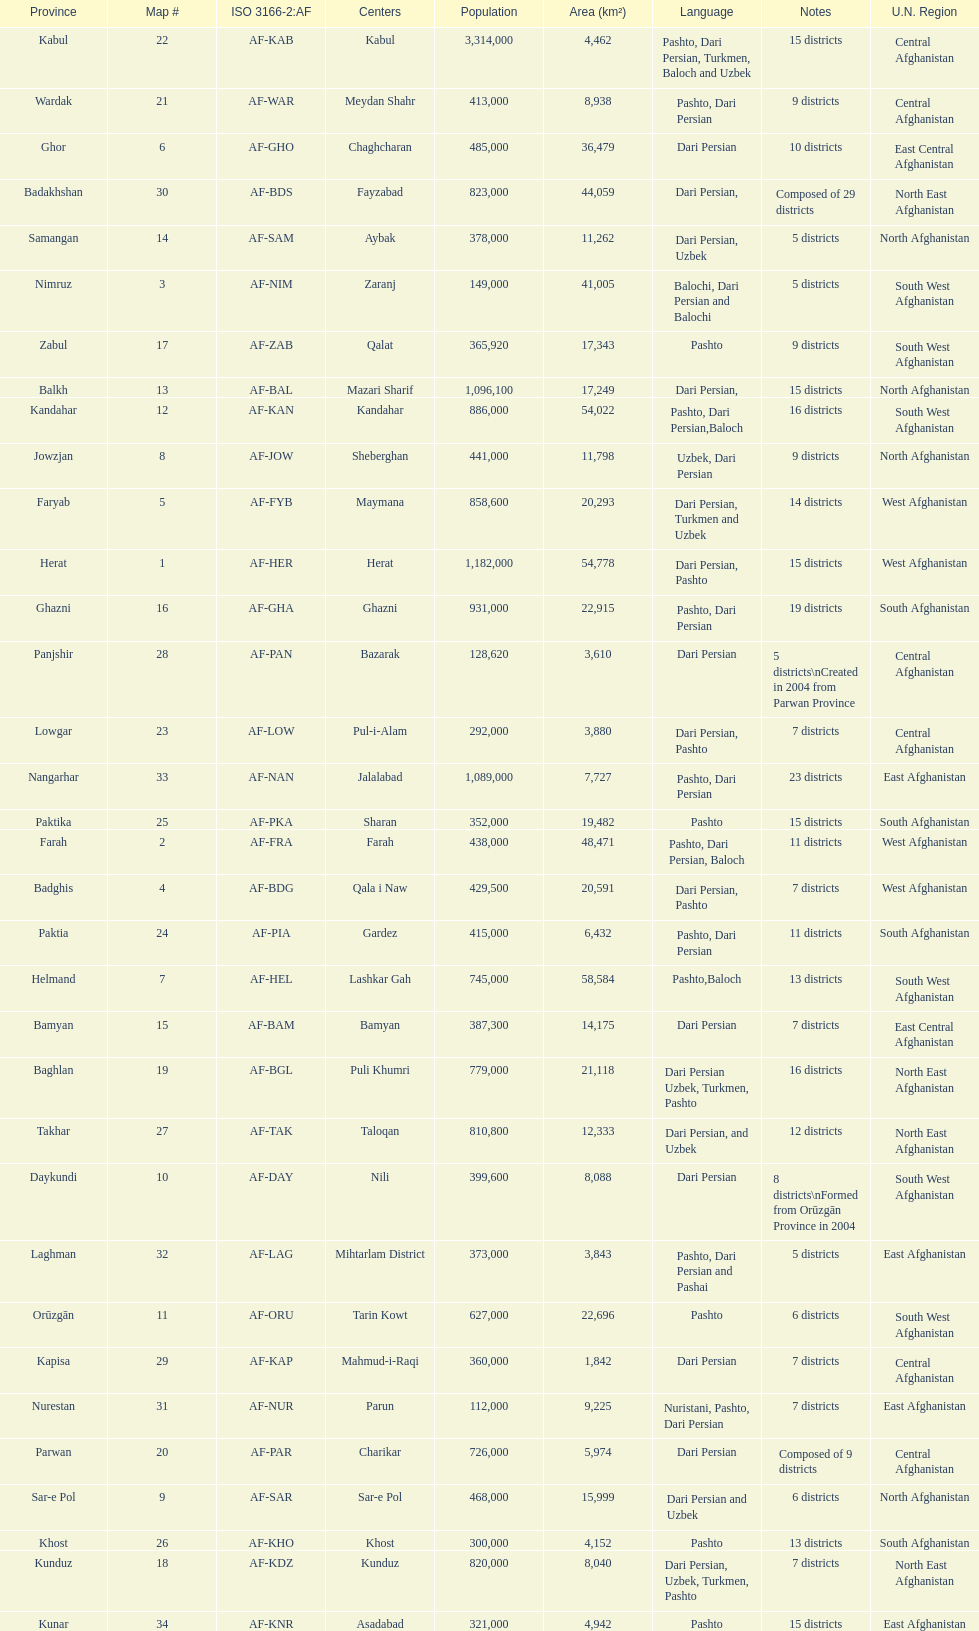How many provinces in afghanistan speak dari persian? 28. 